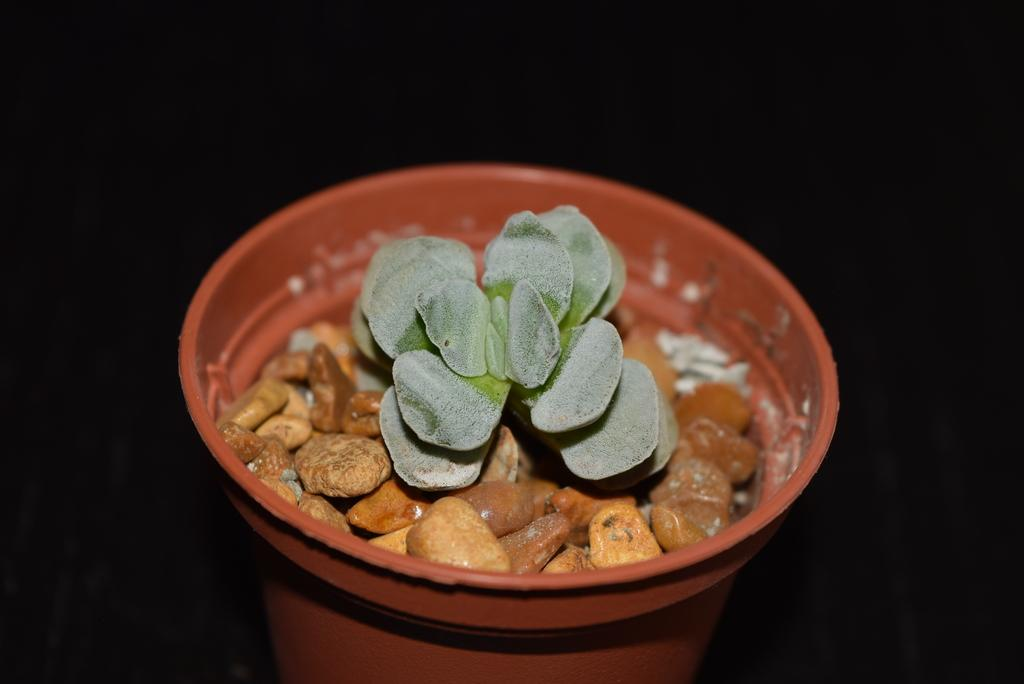What type of living organism is in the image? There is a plant in the image. What is the color of the pot that the plant is in? The plant is in a brown color pot. What other objects are in the pot with the plant? There are stones in the pot. What can be observed about the background of the image? The background of the image is dark in color. Can you see a kite flying in the background of the image? No, there is no kite visible in the image. Is there any ice present in the pot with the plant? No, there are no references to ice in the image. 